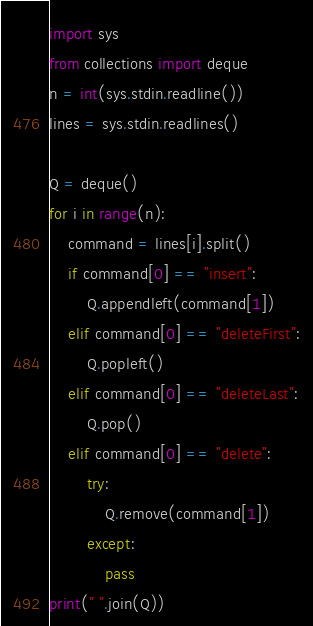<code> <loc_0><loc_0><loc_500><loc_500><_Python_>import sys
from collections import deque
n = int(sys.stdin.readline())
lines = sys.stdin.readlines()
 
Q = deque()
for i in range(n):
    command = lines[i].split()
    if command[0] == "insert":
        Q.appendleft(command[1])
    elif command[0] == "deleteFirst":
        Q.popleft()
    elif command[0] == "deleteLast":
        Q.pop()
    elif command[0] == "delete":
        try:
            Q.remove(command[1])
        except:
            pass
print(" ".join(Q))</code> 